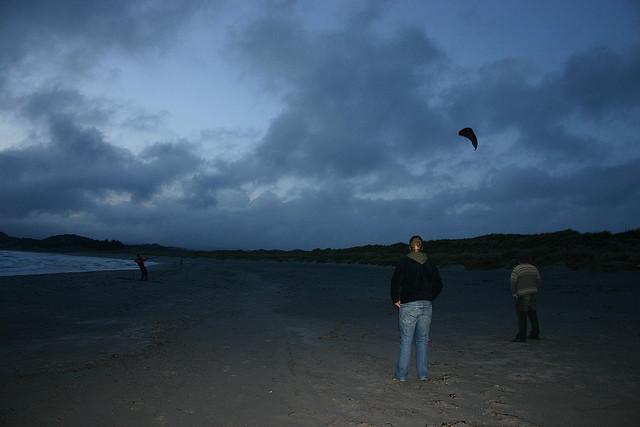How many people are in the photo?
Give a very brief answer. 3. How many people can be seen?
Give a very brief answer. 2. 